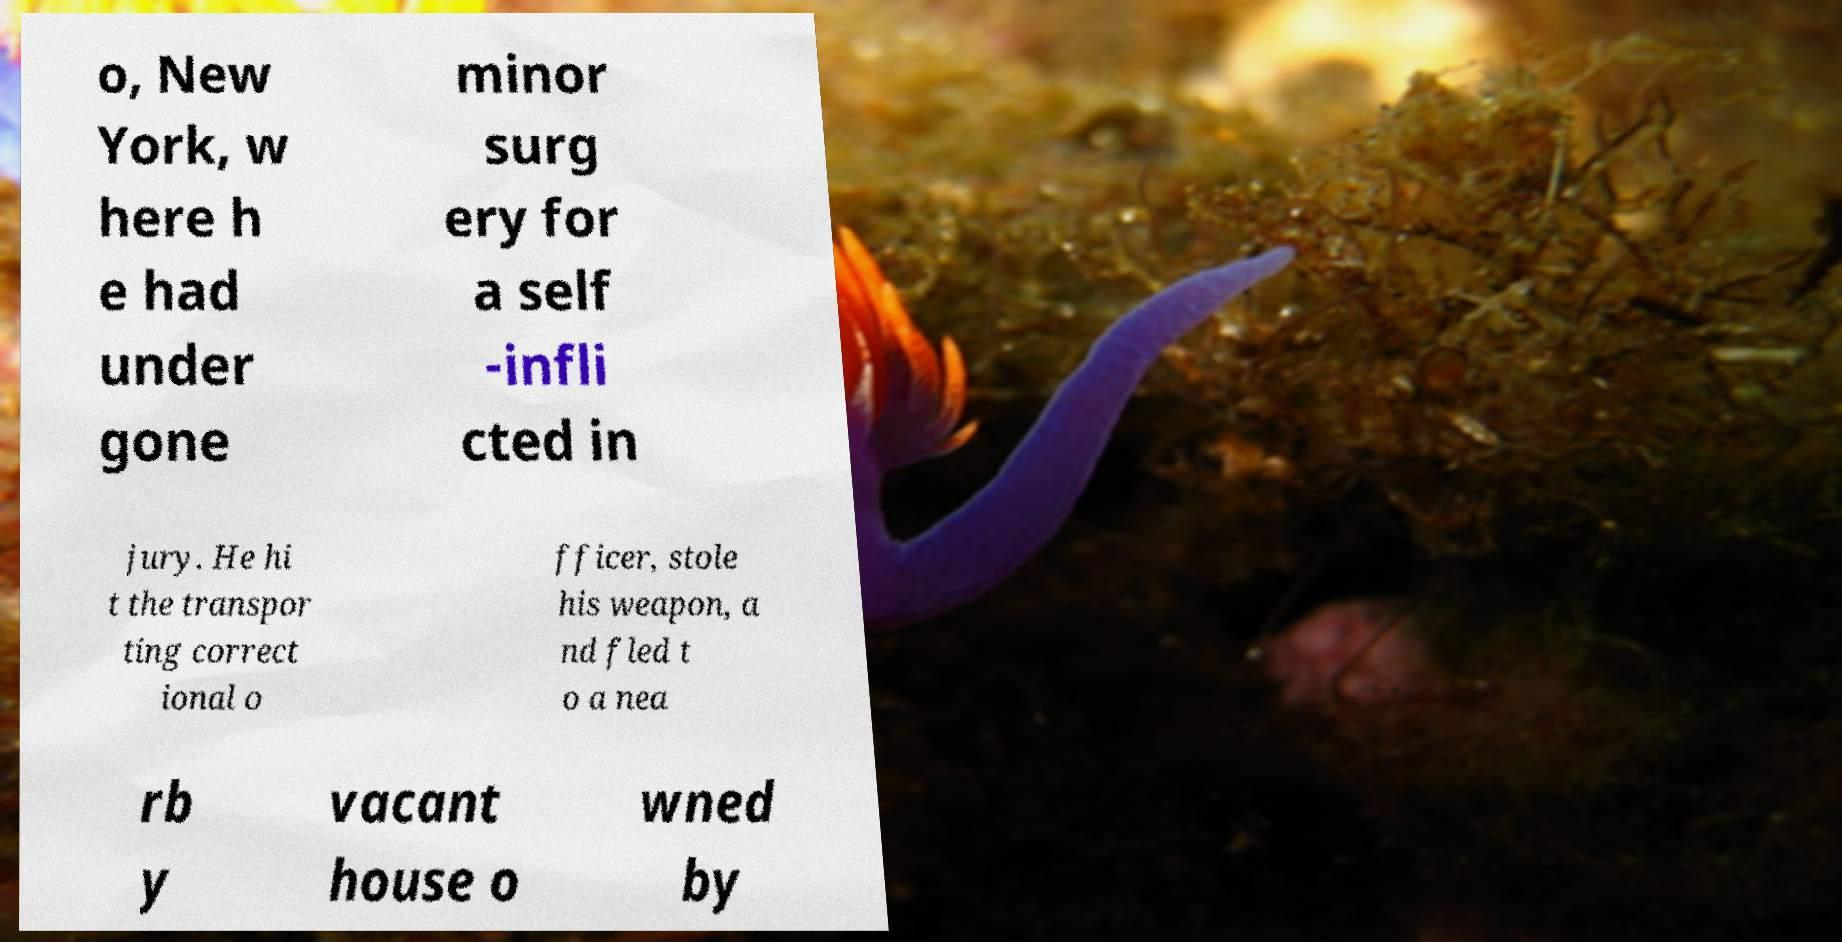For documentation purposes, I need the text within this image transcribed. Could you provide that? o, New York, w here h e had under gone minor surg ery for a self -infli cted in jury. He hi t the transpor ting correct ional o fficer, stole his weapon, a nd fled t o a nea rb y vacant house o wned by 